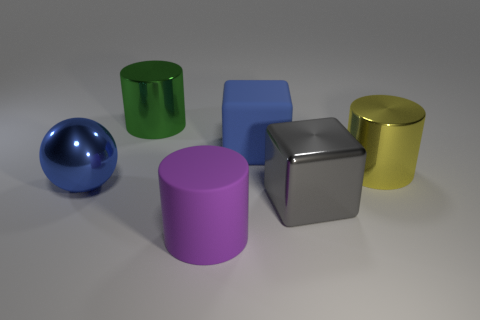Add 4 blue shiny things. How many objects exist? 10 Subtract all blocks. How many objects are left? 4 Add 3 big metal balls. How many big metal balls exist? 4 Subtract 0 gray cylinders. How many objects are left? 6 Subtract all big yellow shiny blocks. Subtract all rubber objects. How many objects are left? 4 Add 3 large things. How many large things are left? 9 